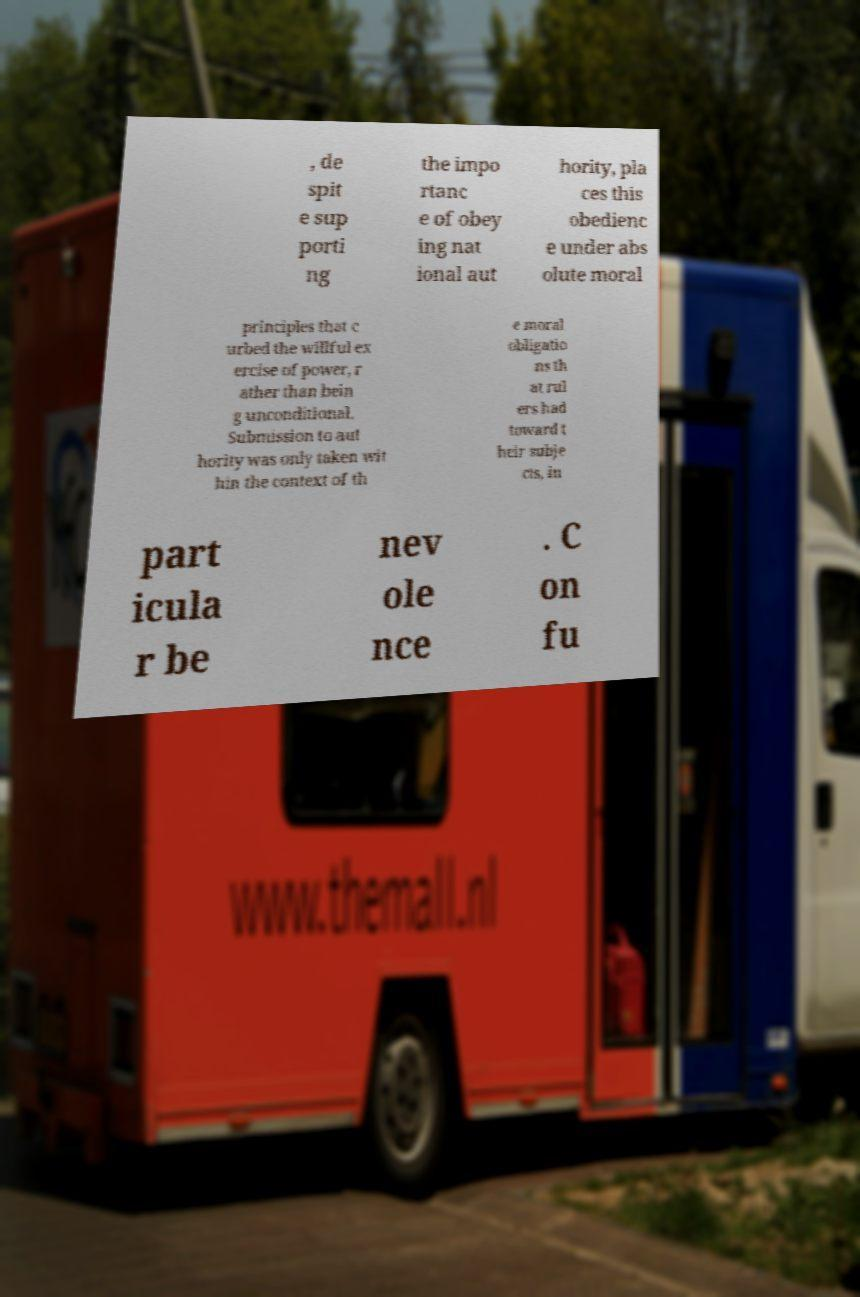Please identify and transcribe the text found in this image. , de spit e sup porti ng the impo rtanc e of obey ing nat ional aut hority, pla ces this obedienc e under abs olute moral principles that c urbed the willful ex ercise of power, r ather than bein g unconditional. Submission to aut hority was only taken wit hin the context of th e moral obligatio ns th at rul ers had toward t heir subje cts, in part icula r be nev ole nce . C on fu 